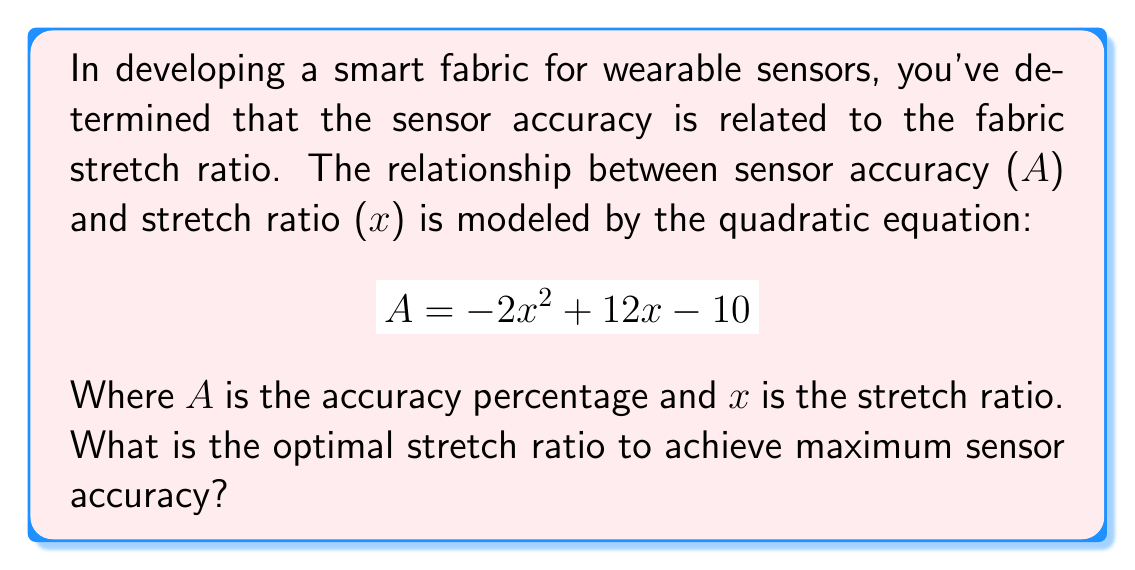Teach me how to tackle this problem. To find the optimal stretch ratio for maximum sensor accuracy, we need to find the vertex of the parabola described by the quadratic equation. The steps are as follows:

1. Identify the quadratic equation in standard form:
   $$A = -2x^2 + 12x - 10$$
   Where $a = -2$, $b = 12$, and $c = -10$

2. Use the formula for the x-coordinate of the vertex: $x = -\frac{b}{2a}$

3. Substitute the values:
   $$x = -\frac{12}{2(-2)} = -\frac{12}{-4} = 3$$

4. The optimal stretch ratio is therefore 3.

5. To verify, we can calculate the y-coordinate (maximum accuracy) by substituting x = 3 into the original equation:
   $$A = -2(3)^2 + 12(3) - 10$$
   $$A = -18 + 36 - 10 = 8$$

This confirms that the vertex (3, 8) represents the maximum point of the parabola, and thus the optimal stretch ratio for maximum sensor accuracy.
Answer: 3 